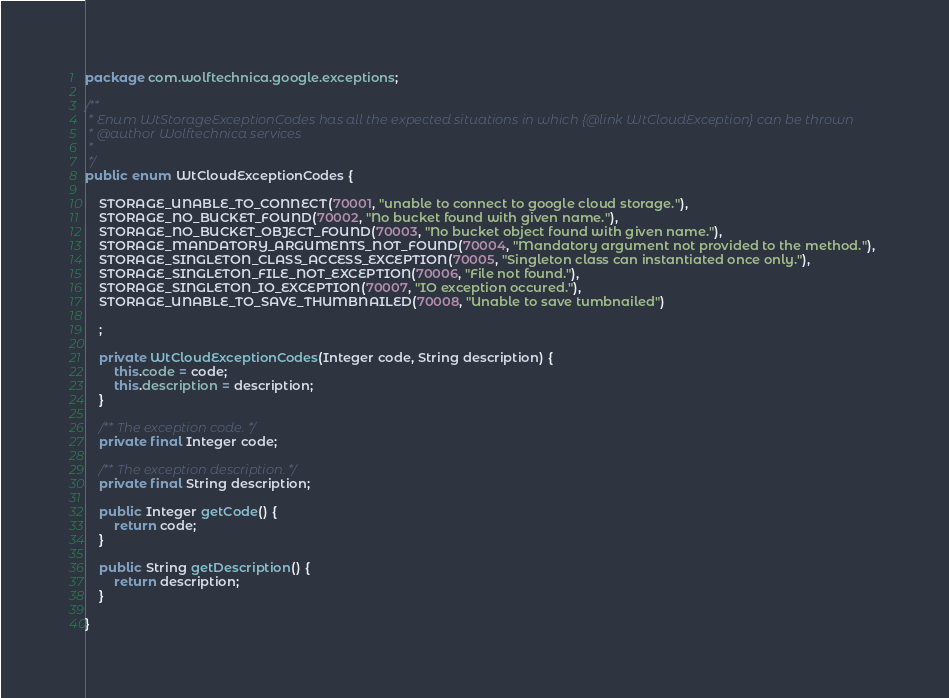Convert code to text. <code><loc_0><loc_0><loc_500><loc_500><_Java_>package com.wolftechnica.google.exceptions;

/**
 * Enum WtStorageExceptionCodes has all the expected situations in which {@link WtCloudException} can be thrown
 * @author Wolftechnica services
 *
 */
public enum WtCloudExceptionCodes {

	STORAGE_UNABLE_TO_CONNECT(70001, "unable to connect to google cloud storage."),
	STORAGE_NO_BUCKET_FOUND(70002, "No bucket found with given name."),
	STORAGE_NO_BUCKET_OBJECT_FOUND(70003, "No bucket object found with given name."),
	STORAGE_MANDATORY_ARGUMENTS_NOT_FOUND(70004, "Mandatory argument not provided to the method."),
	STORAGE_SINGLETON_CLASS_ACCESS_EXCEPTION(70005, "Singleton class can instantiated once only."),
	STORAGE_SINGLETON_FILE_NOT_EXCEPTION(70006, "File not found."),
	STORAGE_SINGLETON_IO_EXCEPTION(70007, "IO exception occured."),
	STORAGE_UNABLE_TO_SAVE_THUMBNAILED(70008, "Unable to save tumbnailed")

	;

	private WtCloudExceptionCodes(Integer code, String description) {
		this.code = code;
		this.description = description;
	}

	/** The exception code. */
	private final Integer code;

	/** The exception description. */
	private final String description;

	public Integer getCode() {
		return code;
	}

	public String getDescription() {
		return description;
	}

}
</code> 